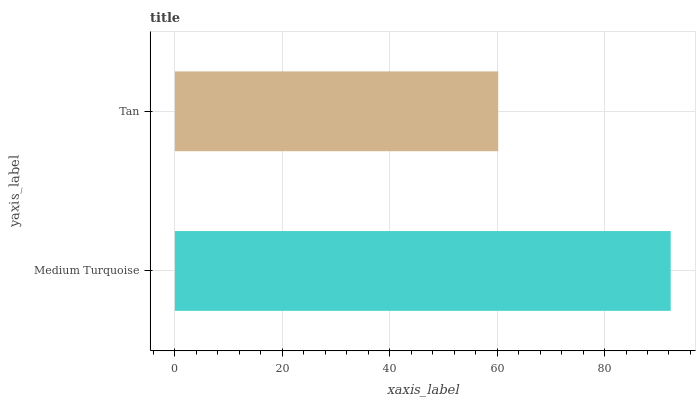Is Tan the minimum?
Answer yes or no. Yes. Is Medium Turquoise the maximum?
Answer yes or no. Yes. Is Tan the maximum?
Answer yes or no. No. Is Medium Turquoise greater than Tan?
Answer yes or no. Yes. Is Tan less than Medium Turquoise?
Answer yes or no. Yes. Is Tan greater than Medium Turquoise?
Answer yes or no. No. Is Medium Turquoise less than Tan?
Answer yes or no. No. Is Medium Turquoise the high median?
Answer yes or no. Yes. Is Tan the low median?
Answer yes or no. Yes. Is Tan the high median?
Answer yes or no. No. Is Medium Turquoise the low median?
Answer yes or no. No. 